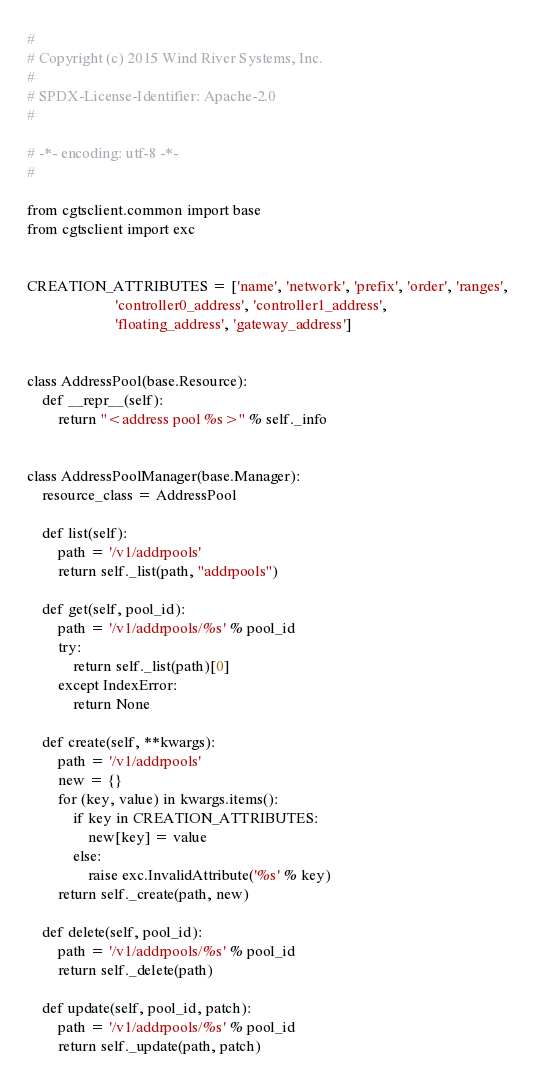Convert code to text. <code><loc_0><loc_0><loc_500><loc_500><_Python_>#
# Copyright (c) 2015 Wind River Systems, Inc.
#
# SPDX-License-Identifier: Apache-2.0
#

# -*- encoding: utf-8 -*-
#

from cgtsclient.common import base
from cgtsclient import exc


CREATION_ATTRIBUTES = ['name', 'network', 'prefix', 'order', 'ranges',
                       'controller0_address', 'controller1_address',
                       'floating_address', 'gateway_address']


class AddressPool(base.Resource):
    def __repr__(self):
        return "<address pool %s>" % self._info


class AddressPoolManager(base.Manager):
    resource_class = AddressPool

    def list(self):
        path = '/v1/addrpools'
        return self._list(path, "addrpools")

    def get(self, pool_id):
        path = '/v1/addrpools/%s' % pool_id
        try:
            return self._list(path)[0]
        except IndexError:
            return None

    def create(self, **kwargs):
        path = '/v1/addrpools'
        new = {}
        for (key, value) in kwargs.items():
            if key in CREATION_ATTRIBUTES:
                new[key] = value
            else:
                raise exc.InvalidAttribute('%s' % key)
        return self._create(path, new)

    def delete(self, pool_id):
        path = '/v1/addrpools/%s' % pool_id
        return self._delete(path)

    def update(self, pool_id, patch):
        path = '/v1/addrpools/%s' % pool_id
        return self._update(path, patch)
</code> 